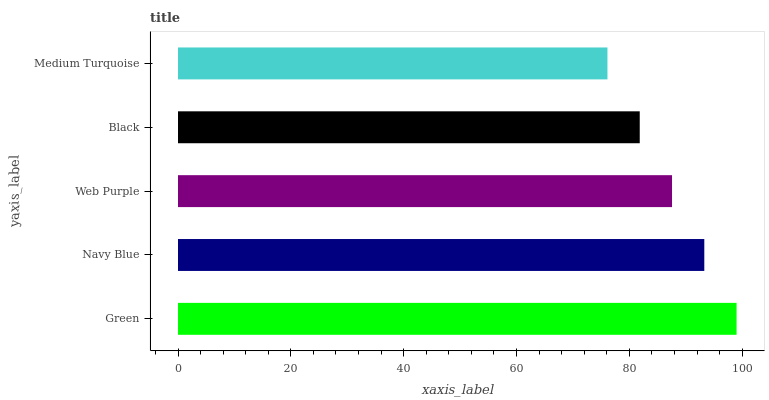Is Medium Turquoise the minimum?
Answer yes or no. Yes. Is Green the maximum?
Answer yes or no. Yes. Is Navy Blue the minimum?
Answer yes or no. No. Is Navy Blue the maximum?
Answer yes or no. No. Is Green greater than Navy Blue?
Answer yes or no. Yes. Is Navy Blue less than Green?
Answer yes or no. Yes. Is Navy Blue greater than Green?
Answer yes or no. No. Is Green less than Navy Blue?
Answer yes or no. No. Is Web Purple the high median?
Answer yes or no. Yes. Is Web Purple the low median?
Answer yes or no. Yes. Is Medium Turquoise the high median?
Answer yes or no. No. Is Green the low median?
Answer yes or no. No. 